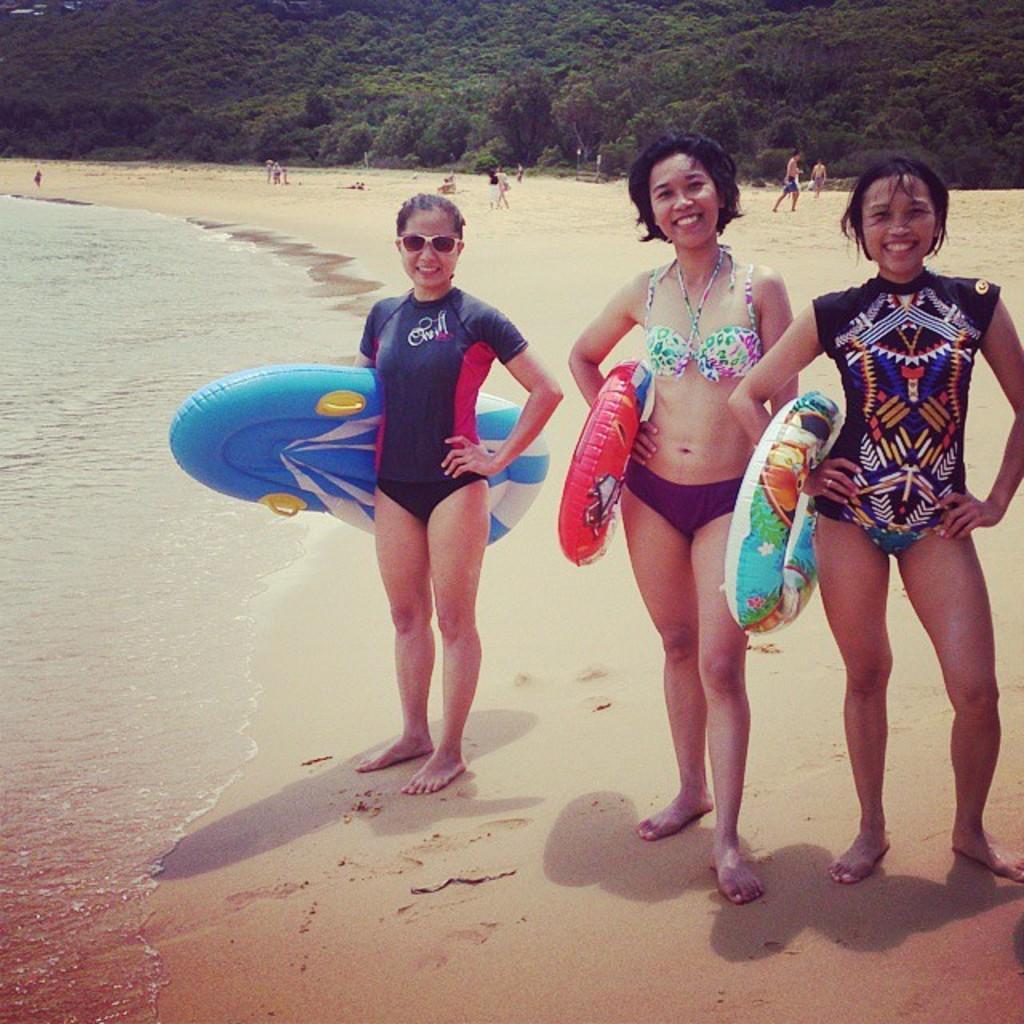Please provide a concise description of this image. In the center of the image there are three ladies standing in a beach and there are holding safety tubes in their hands. At the background of the image there are trees. At the left side of the image there is water. At the bottom of the image there is sand. 